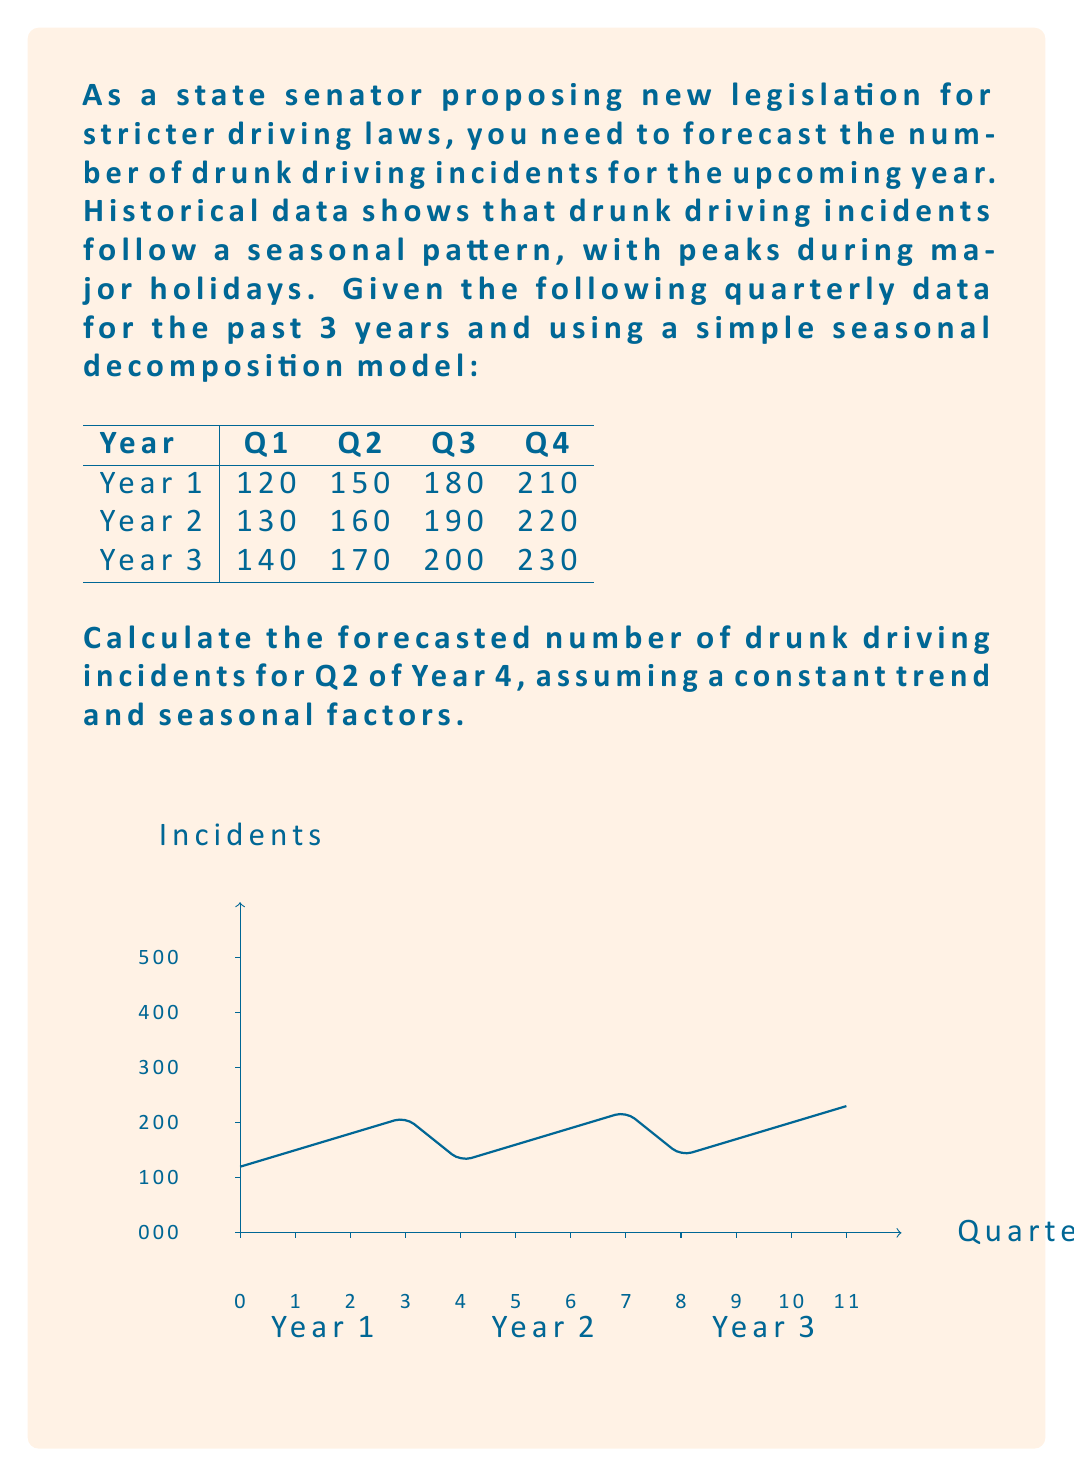Provide a solution to this math problem. To forecast the number of drunk driving incidents for Q2 of Year 4, we'll use a simple seasonal decomposition model. This involves the following steps:

1. Calculate the average for each quarter across all years:
   Q1 avg: (120 + 130 + 140) / 3 = 130
   Q2 avg: (150 + 160 + 170) / 3 = 160
   Q3 avg: (180 + 190 + 200) / 3 = 190
   Q4 avg: (210 + 220 + 230) / 3 = 220

2. Calculate the overall average:
   Overall avg = (130 + 160 + 190 + 220) / 4 = 175

3. Calculate seasonal factors:
   Q1 factor: 130 / 175 = 0.743
   Q2 factor: 160 / 175 = 0.914
   Q3 factor: 190 / 175 = 1.086
   Q4 factor: 220 / 175 = 1.257

4. Calculate the trend:
   Year 1 avg: (120 + 150 + 180 + 210) / 4 = 165
   Year 2 avg: (130 + 160 + 190 + 220) / 4 = 175
   Year 3 avg: (140 + 170 + 200 + 230) / 4 = 185
   
   Trend = (185 - 165) / 2 = 10 incidents/year

5. Forecast for Year 4 Q2:
   Base forecast = Year 3 avg + Trend = 185 + 10 = 195
   Q2 forecast = Base forecast × Q2 factor = 195 × 0.914 ≈ 178.23

Therefore, the forecasted number of drunk driving incidents for Q2 of Year 4 is approximately 178.
Answer: 178 incidents 